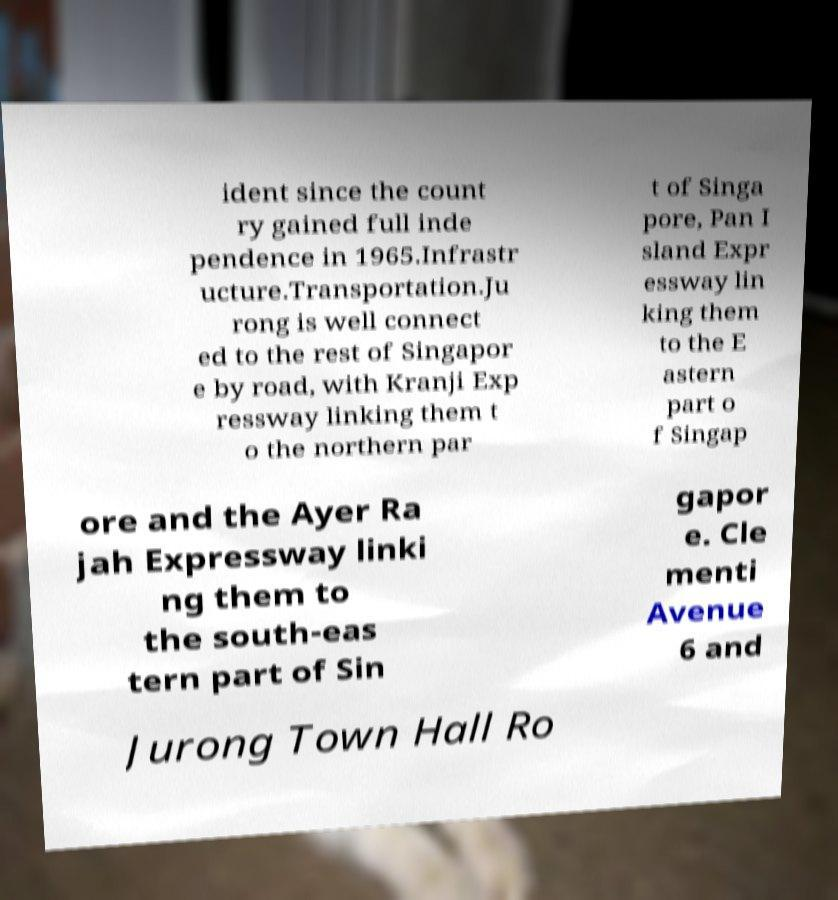Could you extract and type out the text from this image? ident since the count ry gained full inde pendence in 1965.Infrastr ucture.Transportation.Ju rong is well connect ed to the rest of Singapor e by road, with Kranji Exp ressway linking them t o the northern par t of Singa pore, Pan I sland Expr essway lin king them to the E astern part o f Singap ore and the Ayer Ra jah Expressway linki ng them to the south-eas tern part of Sin gapor e. Cle menti Avenue 6 and Jurong Town Hall Ro 